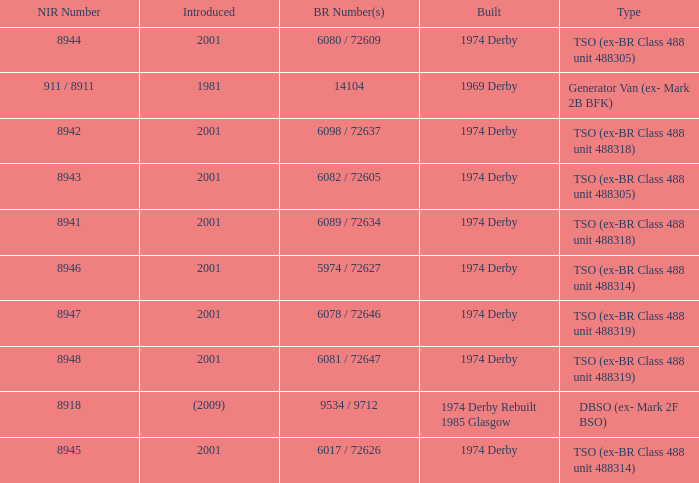Which NIR number is for the tso (ex-br class 488 unit 488305) type that has a 6082 / 72605 BR number? 8943.0. 